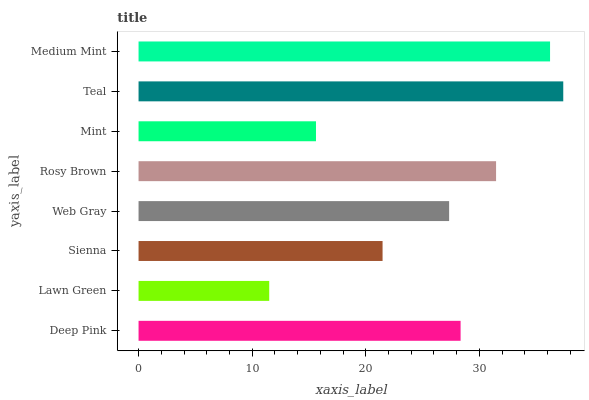Is Lawn Green the minimum?
Answer yes or no. Yes. Is Teal the maximum?
Answer yes or no. Yes. Is Sienna the minimum?
Answer yes or no. No. Is Sienna the maximum?
Answer yes or no. No. Is Sienna greater than Lawn Green?
Answer yes or no. Yes. Is Lawn Green less than Sienna?
Answer yes or no. Yes. Is Lawn Green greater than Sienna?
Answer yes or no. No. Is Sienna less than Lawn Green?
Answer yes or no. No. Is Deep Pink the high median?
Answer yes or no. Yes. Is Web Gray the low median?
Answer yes or no. Yes. Is Teal the high median?
Answer yes or no. No. Is Teal the low median?
Answer yes or no. No. 